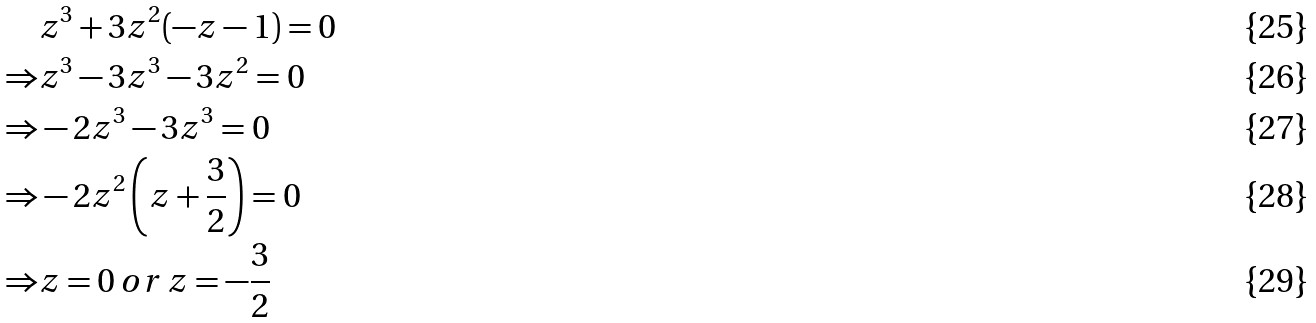Convert formula to latex. <formula><loc_0><loc_0><loc_500><loc_500>& z ^ { 3 } + 3 z ^ { 2 } ( - z - 1 ) = 0 \\ \Rightarrow & z ^ { 3 } - 3 z ^ { 3 } - 3 z ^ { 2 } = 0 \\ \Rightarrow & - 2 z ^ { 3 } - 3 z ^ { 3 } = 0 \\ \Rightarrow & - 2 z ^ { 2 } \left ( z + \frac { 3 } { 2 } \right ) = 0 \\ \Rightarrow & z = 0 \, o r \, z = - \frac { 3 } { 2 }</formula> 